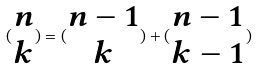<formula> <loc_0><loc_0><loc_500><loc_500>( \begin{matrix} n \\ k \end{matrix} ) = ( \begin{matrix} n - 1 \\ k \end{matrix} ) + ( \begin{matrix} n - 1 \\ k - 1 \end{matrix} )</formula> 